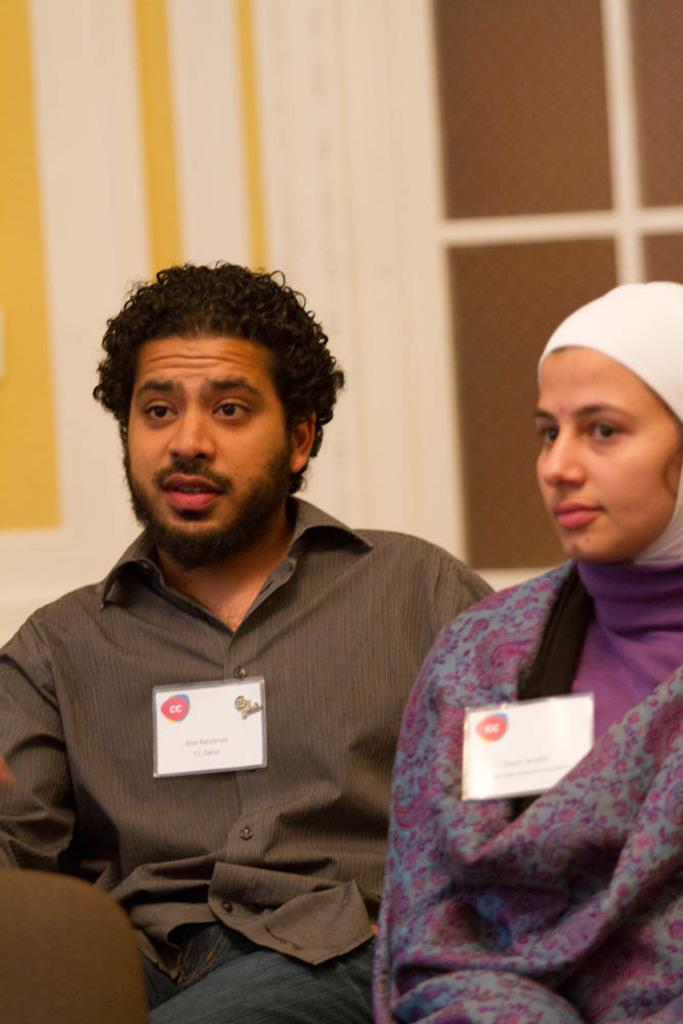How many people are in the image? There are two people in the image, a man and a woman. What are the man and woman doing in the image? The man and woman are sitting. What objects can be seen in the image besides the man and woman? There are two cards in the image. What can be seen in the background of the image? There is a wall in the background of the image. What type of church is visible in the background of the image? There is no church visible in the background of the image; it features a wall. How many brothers are present in the image? There is no mention of brothers in the image; it only features a man and a woman. 